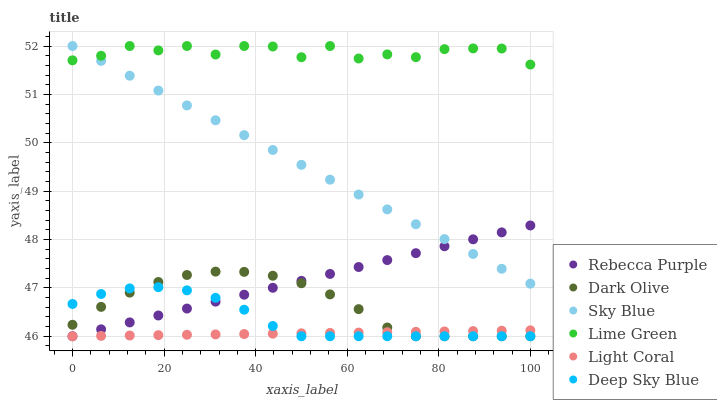Does Light Coral have the minimum area under the curve?
Answer yes or no. Yes. Does Lime Green have the maximum area under the curve?
Answer yes or no. Yes. Does Rebecca Purple have the minimum area under the curve?
Answer yes or no. No. Does Rebecca Purple have the maximum area under the curve?
Answer yes or no. No. Is Rebecca Purple the smoothest?
Answer yes or no. Yes. Is Lime Green the roughest?
Answer yes or no. Yes. Is Light Coral the smoothest?
Answer yes or no. No. Is Light Coral the roughest?
Answer yes or no. No. Does Dark Olive have the lowest value?
Answer yes or no. Yes. Does Sky Blue have the lowest value?
Answer yes or no. No. Does Lime Green have the highest value?
Answer yes or no. Yes. Does Rebecca Purple have the highest value?
Answer yes or no. No. Is Light Coral less than Lime Green?
Answer yes or no. Yes. Is Lime Green greater than Dark Olive?
Answer yes or no. Yes. Does Light Coral intersect Deep Sky Blue?
Answer yes or no. Yes. Is Light Coral less than Deep Sky Blue?
Answer yes or no. No. Is Light Coral greater than Deep Sky Blue?
Answer yes or no. No. Does Light Coral intersect Lime Green?
Answer yes or no. No. 